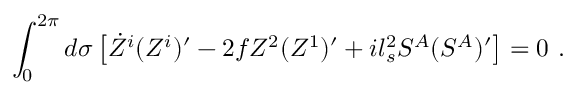Convert formula to latex. <formula><loc_0><loc_0><loc_500><loc_500>\int _ { 0 } ^ { 2 \pi } d \sigma \left [ \dot { Z } ^ { i } ( Z ^ { i } ) ^ { \prime } - 2 f Z ^ { 2 } ( Z ^ { 1 } ) ^ { \prime } + i l _ { s } ^ { 2 } S ^ { A } ( S ^ { A } ) ^ { \prime } \right ] = 0 .</formula> 